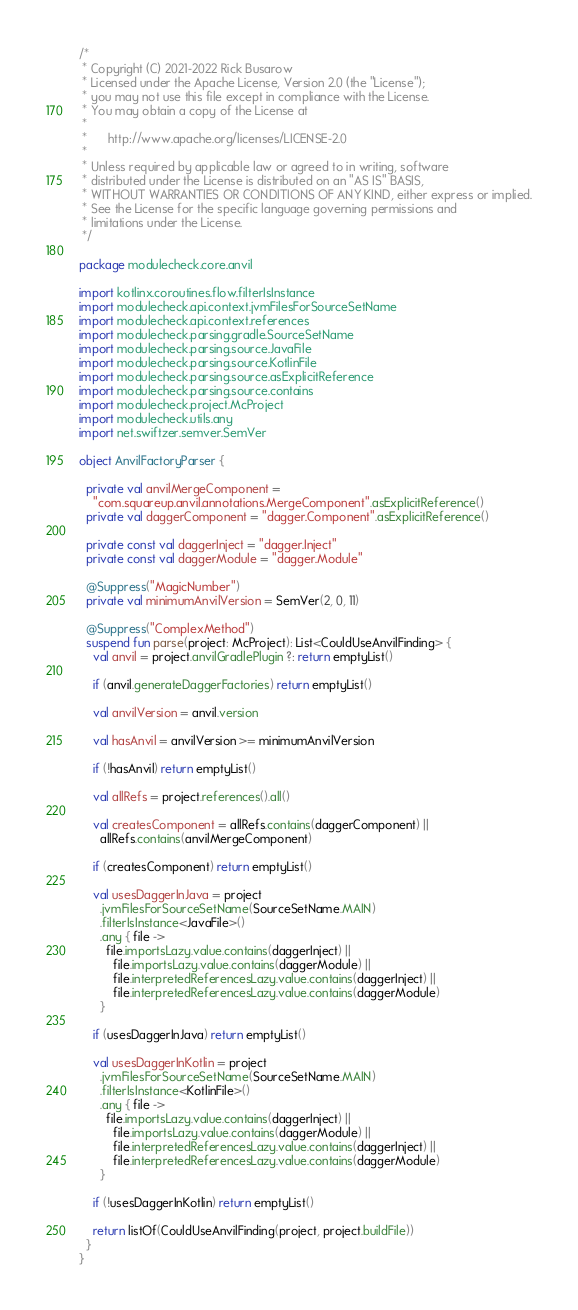Convert code to text. <code><loc_0><loc_0><loc_500><loc_500><_Kotlin_>/*
 * Copyright (C) 2021-2022 Rick Busarow
 * Licensed under the Apache License, Version 2.0 (the "License");
 * you may not use this file except in compliance with the License.
 * You may obtain a copy of the License at
 *
 *      http://www.apache.org/licenses/LICENSE-2.0
 *
 * Unless required by applicable law or agreed to in writing, software
 * distributed under the License is distributed on an "AS IS" BASIS,
 * WITHOUT WARRANTIES OR CONDITIONS OF ANY KIND, either express or implied.
 * See the License for the specific language governing permissions and
 * limitations under the License.
 */

package modulecheck.core.anvil

import kotlinx.coroutines.flow.filterIsInstance
import modulecheck.api.context.jvmFilesForSourceSetName
import modulecheck.api.context.references
import modulecheck.parsing.gradle.SourceSetName
import modulecheck.parsing.source.JavaFile
import modulecheck.parsing.source.KotlinFile
import modulecheck.parsing.source.asExplicitReference
import modulecheck.parsing.source.contains
import modulecheck.project.McProject
import modulecheck.utils.any
import net.swiftzer.semver.SemVer

object AnvilFactoryParser {

  private val anvilMergeComponent =
    "com.squareup.anvil.annotations.MergeComponent".asExplicitReference()
  private val daggerComponent = "dagger.Component".asExplicitReference()

  private const val daggerInject = "dagger.Inject"
  private const val daggerModule = "dagger.Module"

  @Suppress("MagicNumber")
  private val minimumAnvilVersion = SemVer(2, 0, 11)

  @Suppress("ComplexMethod")
  suspend fun parse(project: McProject): List<CouldUseAnvilFinding> {
    val anvil = project.anvilGradlePlugin ?: return emptyList()

    if (anvil.generateDaggerFactories) return emptyList()

    val anvilVersion = anvil.version

    val hasAnvil = anvilVersion >= minimumAnvilVersion

    if (!hasAnvil) return emptyList()

    val allRefs = project.references().all()

    val createsComponent = allRefs.contains(daggerComponent) ||
      allRefs.contains(anvilMergeComponent)

    if (createsComponent) return emptyList()

    val usesDaggerInJava = project
      .jvmFilesForSourceSetName(SourceSetName.MAIN)
      .filterIsInstance<JavaFile>()
      .any { file ->
        file.importsLazy.value.contains(daggerInject) ||
          file.importsLazy.value.contains(daggerModule) ||
          file.interpretedReferencesLazy.value.contains(daggerInject) ||
          file.interpretedReferencesLazy.value.contains(daggerModule)
      }

    if (usesDaggerInJava) return emptyList()

    val usesDaggerInKotlin = project
      .jvmFilesForSourceSetName(SourceSetName.MAIN)
      .filterIsInstance<KotlinFile>()
      .any { file ->
        file.importsLazy.value.contains(daggerInject) ||
          file.importsLazy.value.contains(daggerModule) ||
          file.interpretedReferencesLazy.value.contains(daggerInject) ||
          file.interpretedReferencesLazy.value.contains(daggerModule)
      }

    if (!usesDaggerInKotlin) return emptyList()

    return listOf(CouldUseAnvilFinding(project, project.buildFile))
  }
}
</code> 